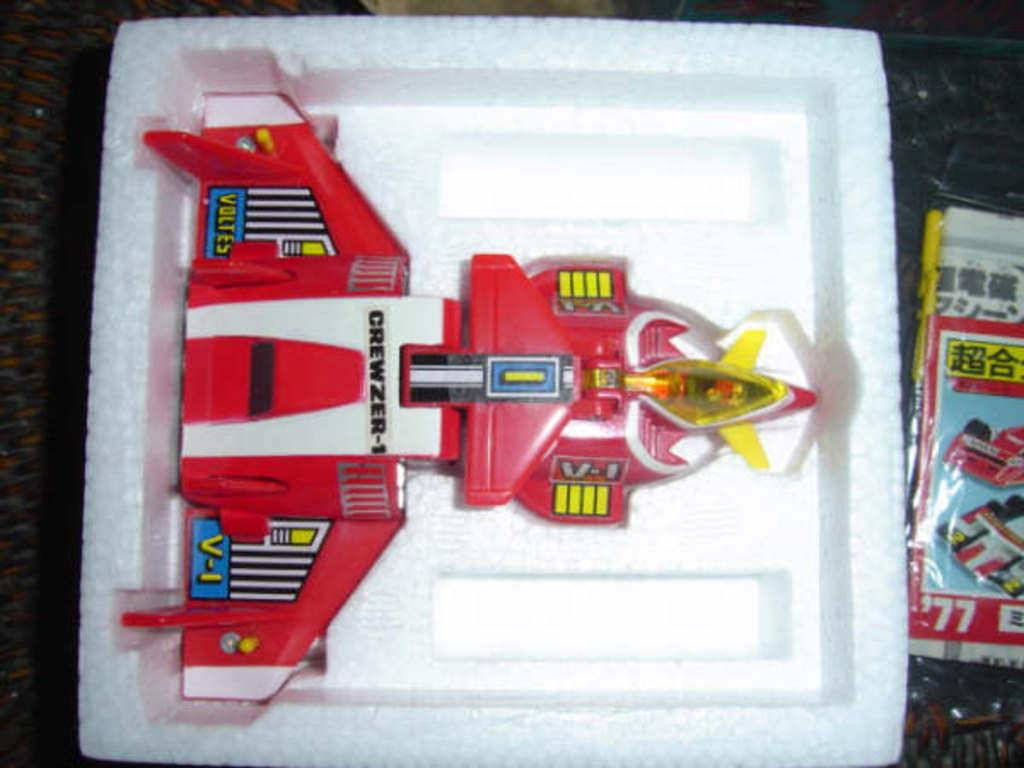What is placed on the thermocol box in the image? There is a toy placed on a thermocol box. What is covering the thermocol box? There is a plastic cover with a poster placed on the thermocol box. Where are the objects located in the image? The objects are placed on a platform. What type of cannon is depicted on the poster? There is no cannon depicted on the poster; it features a different image or design. What time of day is shown in the image? The image does not depict a specific time of day; it only shows the objects and their arrangement. 